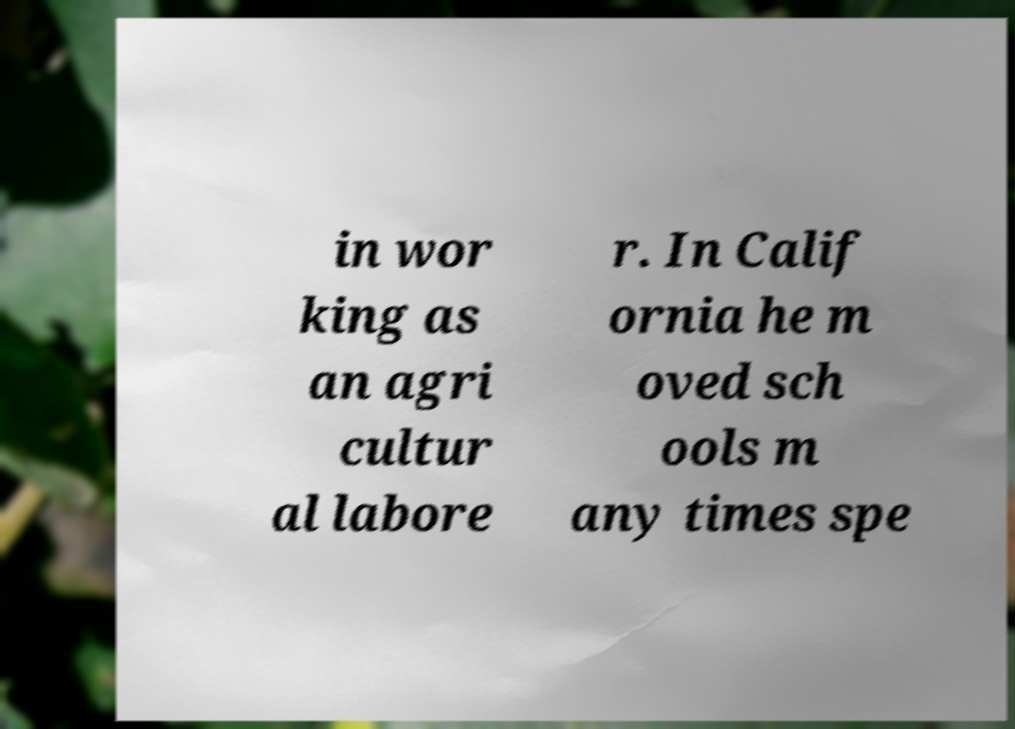I need the written content from this picture converted into text. Can you do that? in wor king as an agri cultur al labore r. In Calif ornia he m oved sch ools m any times spe 